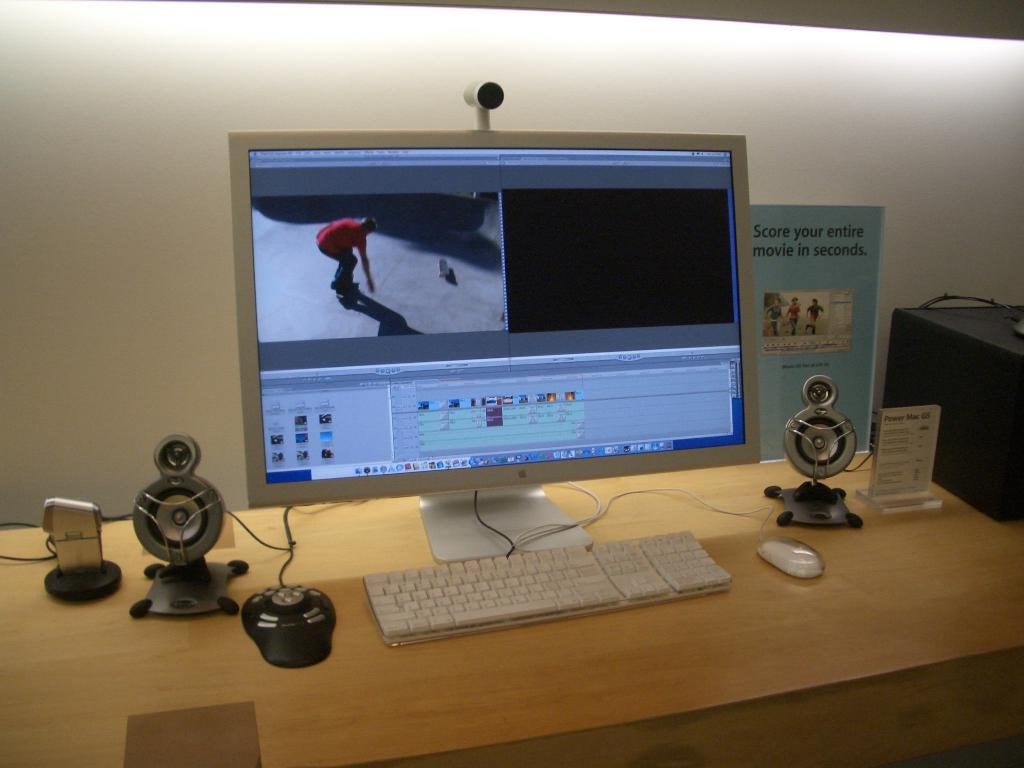What piece of furniture is present in the image? There is a table in the image. What electronic device is on the table? There is a monitor on the table. What input device is on the table? There is a keyboard and a mouse on the table. What award is on the table? There is a trophy on the table. What else can be found on the table? There are electronic devices on the table. What can be seen in the background of the image? There is a wall in the background of the image, and there is a poster on the wall. What type of grape is being used as a paperweight on the table? There is no grape present on the table in the image. How does the magic work to make the monitor levitate above the table? There is no magic present in the image, and the monitor is resting on the table. 